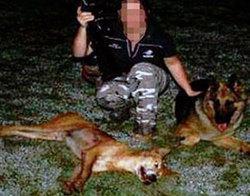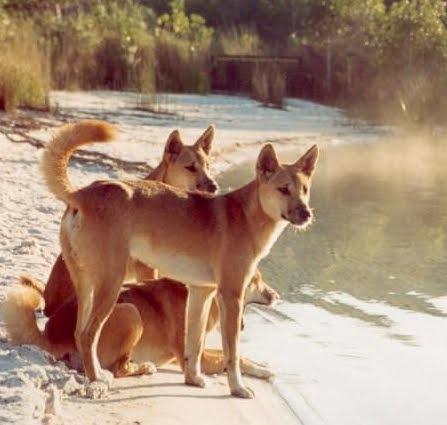The first image is the image on the left, the second image is the image on the right. Evaluate the accuracy of this statement regarding the images: "In at least one image there is a single male in camo clothes holding a hunting gun near the dead brown fox.". Is it true? Answer yes or no. Yes. The first image is the image on the left, the second image is the image on the right. Analyze the images presented: Is the assertion "There is at least two canines in the right image." valid? Answer yes or no. Yes. 